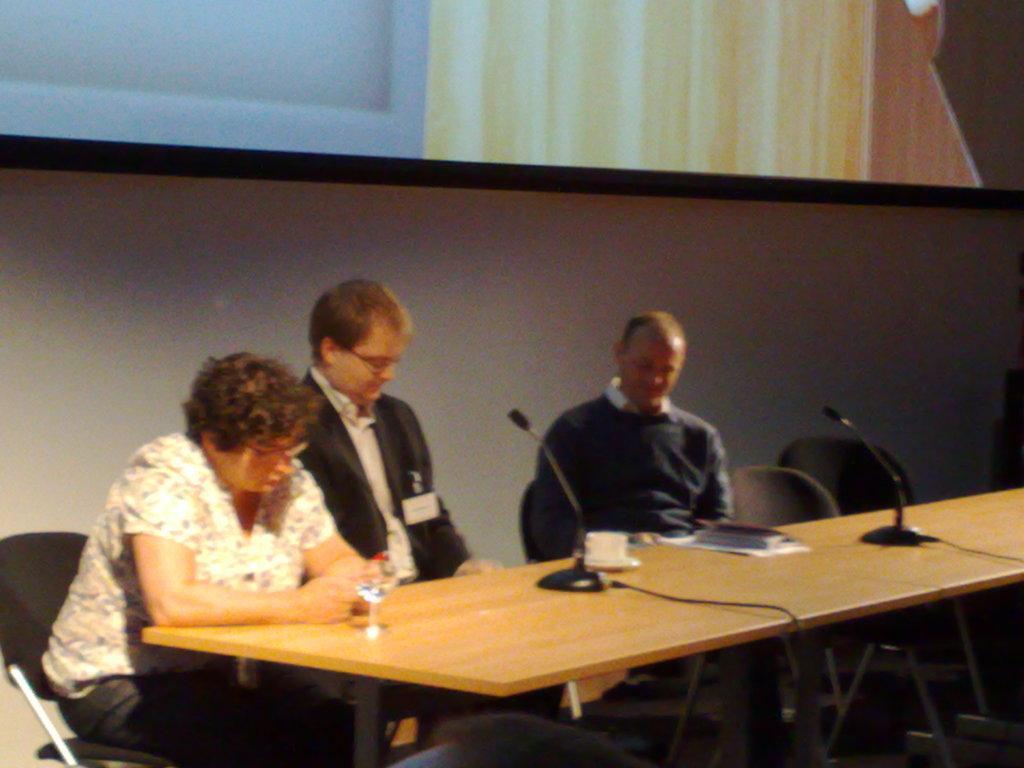Describe this image in one or two sentences. In the image there are three people two men and one women who are sitting on chair behind the table. On table there are microphone,book,paper,glass with some water in background there is a screen and a white color wall. 